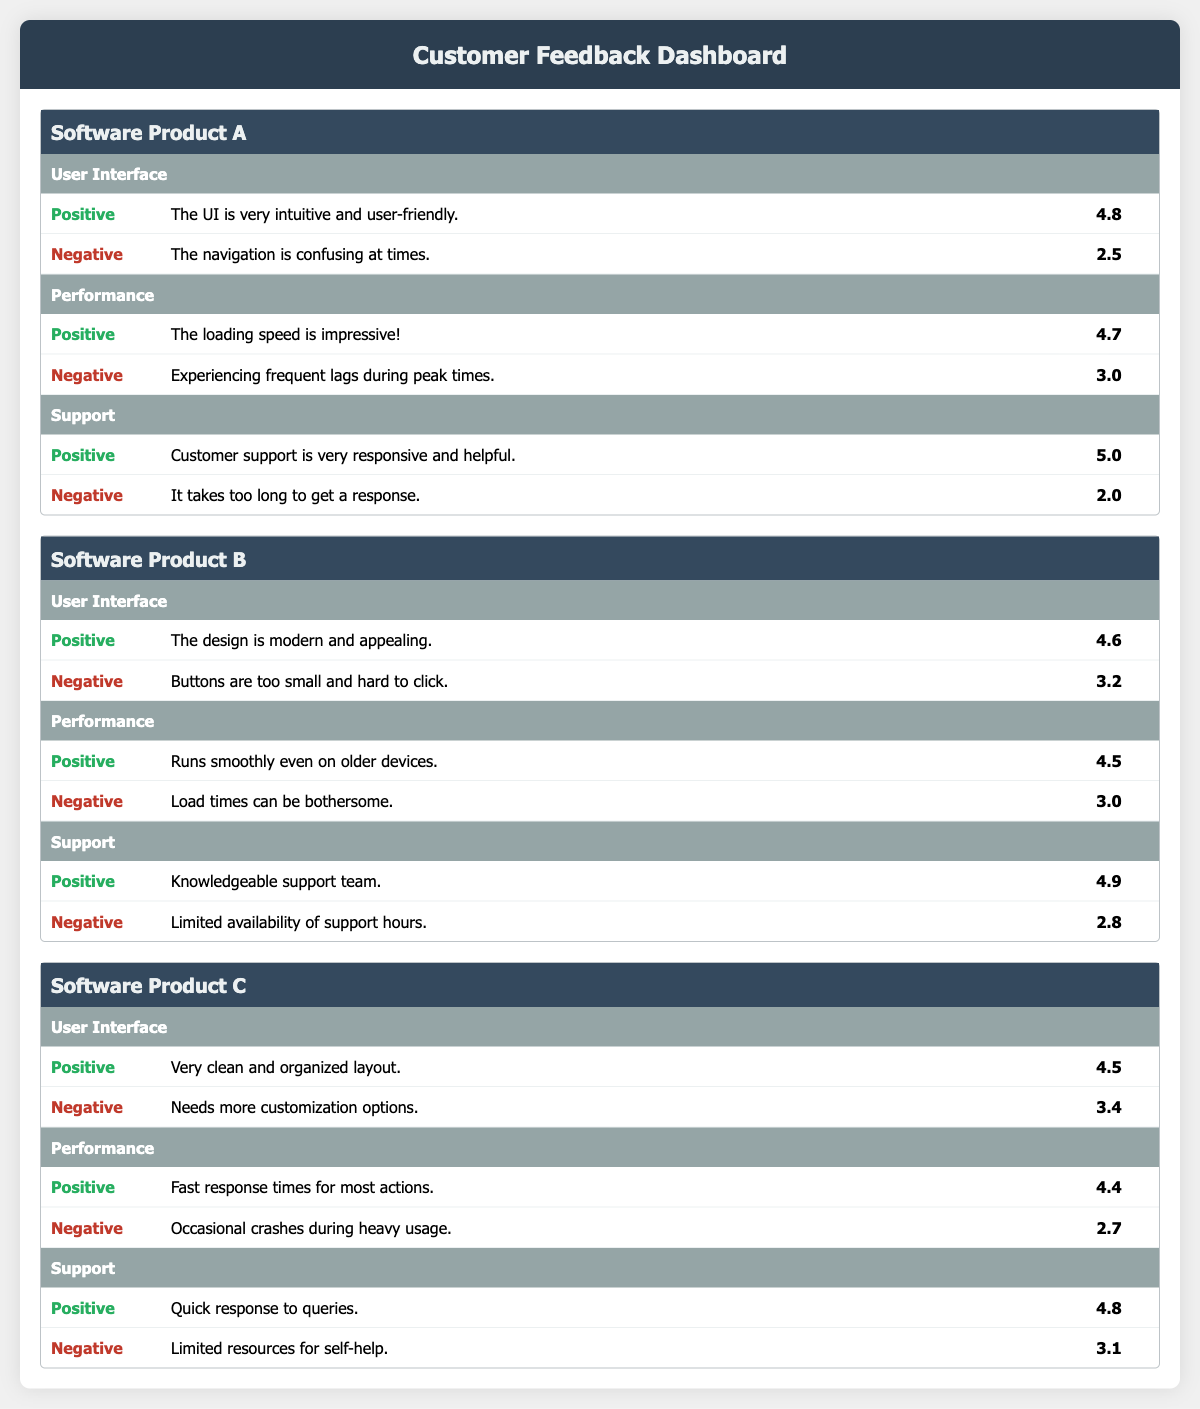What is the highest rating for customer support in Software Product A? The table shows the feedback for Software Product A under the Support category, where the highest rating is 5.0 for the positive comment "Customer support is very responsive and helpful."
Answer: 5.0 What feedback did users provide regarding the User Interface in Software Product B? Under the User Interface category for Software Product B, there is one positive comment with a rating of 4.6 saying "The design is modern and appealing," and one negative comment with a rating of 3.2 stating "Buttons are too small and hard to click."
Answer: Positive: 4.6, Negative: 3.2 Are there more positive or negative comments for Software Product C regarding performance? For Software Product C, there are two comments on performance: the positive comment has a rating of 4.4 and the negative comment has a rating of 2.7. Since both categories have one comment each, there is no greater quantity for either positive or negative comments.
Answer: Equal What is the average rating for user interface feedback across all software products? The ratings for User Interface feedback are: Software Product A (4.8, 2.5), Software Product B (4.6, 3.2), and Software Product C (4.5, 3.4). Summing all ratings gives 4.8 + 2.5 + 4.6 + 3.2 + 4.5 + 3.4 = 23.0. There are 6 ratings, so the average is 23.0 / 6 = 3.83.
Answer: 3.83 Did Software Product A receive higher ratings for performance compared to Software Product B? Software Product A has a performance rating of 4.7 for positive feedback and 3.0 for negative feedback. Software Product B has a positive rating of 4.5 and a negative rating of 3.0. Comparing these, Software Product A's positive feedback rating (4.7) is higher than Software Product B’s (4.5).
Answer: Yes 